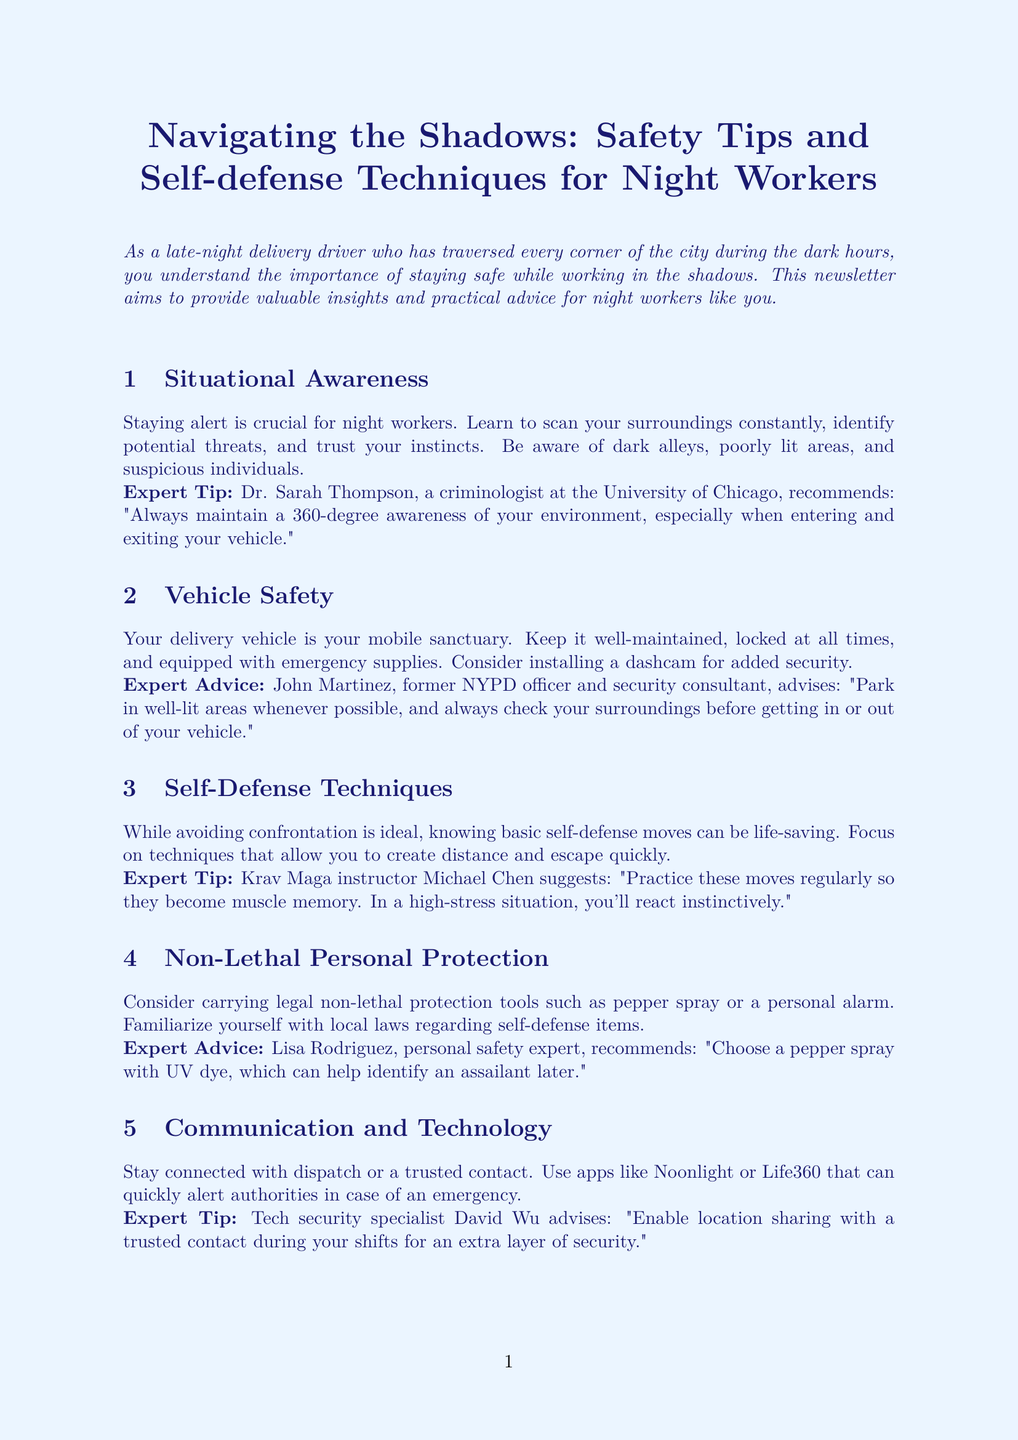What is the title of the newsletter? The title of the newsletter is stated in the document as "Navigating the Shadows: Safety Tips and Self-defense Techniques for Night Workers."
Answer: Navigating the Shadows: Safety Tips and Self-defense Techniques for Night Workers Who provides the expert tip on situational awareness? The document states that Dr. Sarah Thompson provides the expert tip on situational awareness.
Answer: Dr. Sarah Thompson What should you do with your delivery vehicle according to the vehicle safety section? The vehicle safety section emphasizes that the delivery vehicle should be locked at all times and well-maintained.
Answer: Locked at all times What is one recommended self-defense technique mentioned? The self-defense techniques section mentions the palm heel strike as a recommended move.
Answer: Palm heel strike Which personal protection tool is suggested? The document suggests carrying legal non-lethal protection tools such as pepper spray.
Answer: Pepper spray What is a recommended app for communication and technology? The communication and technology section mentions the app Noonlight as a recommended tool.
Answer: Noonlight What does urban planner Robert Kim suggest for route planning? Robert Kim advises creating a mental map of safe havens along regular routes for route planning.
Answer: Mental map of safe havens How many expert tips are provided in total throughout the newsletter? The newsletter includes a total of six expert tips, one per section except for the conclusion.
Answer: Six What is emphasized as paramount in the conclusion? The conclusion emphasizes that "your safety is paramount."
Answer: Your safety is paramount 